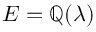<formula> <loc_0><loc_0><loc_500><loc_500>E = \mathbb { Q } ( \lambda )</formula> 